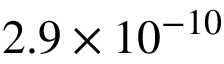Convert formula to latex. <formula><loc_0><loc_0><loc_500><loc_500>2 . 9 \times 1 0 ^ { - 1 0 }</formula> 